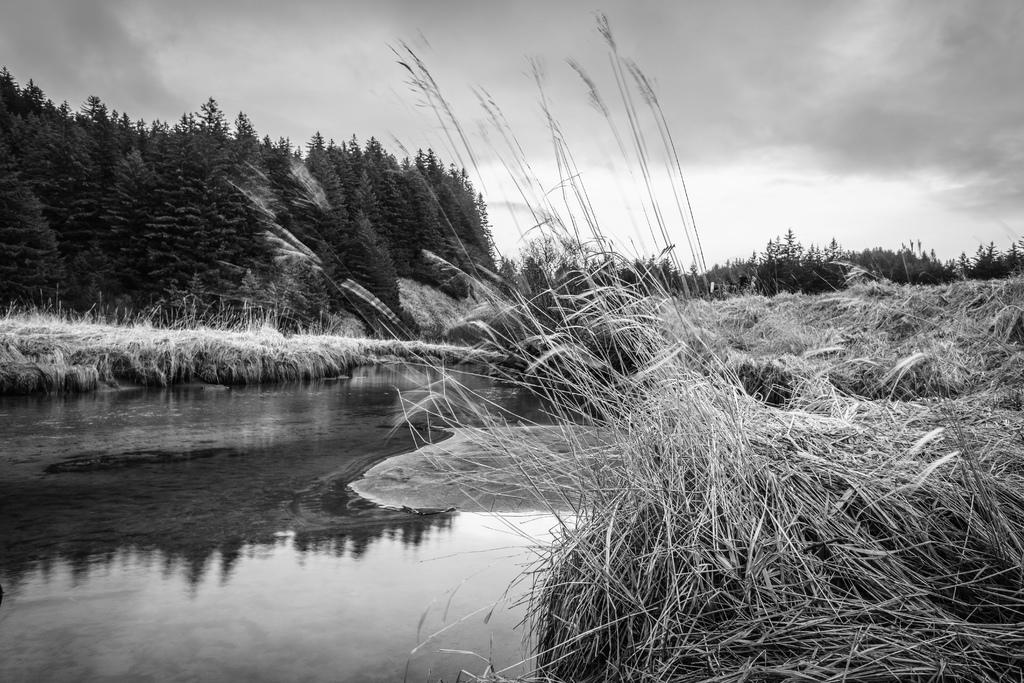What type of water body is located on the left side of the image? There is a pond on the left side of the image. What type of vegetation is on the right side of the image? There is grass on the right side of the image. What can be seen in the background of the image? There are trees and clouds in the sky in the background of the image. What type of apparel is being worn by the trees in the image? There are no people or clothing items present in the image, only trees. Can you hear a whistle in the image? There is no sound or indication of a whistle in the image. 